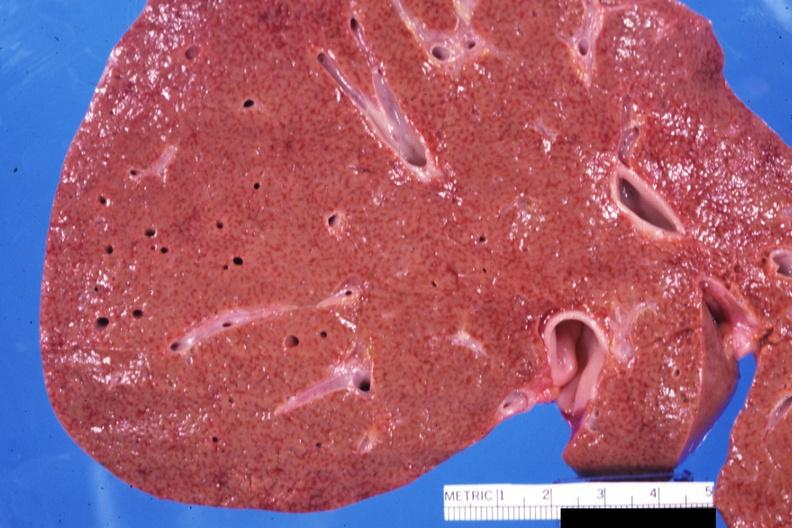s cut present?
Answer the question using a single word or phrase. No 